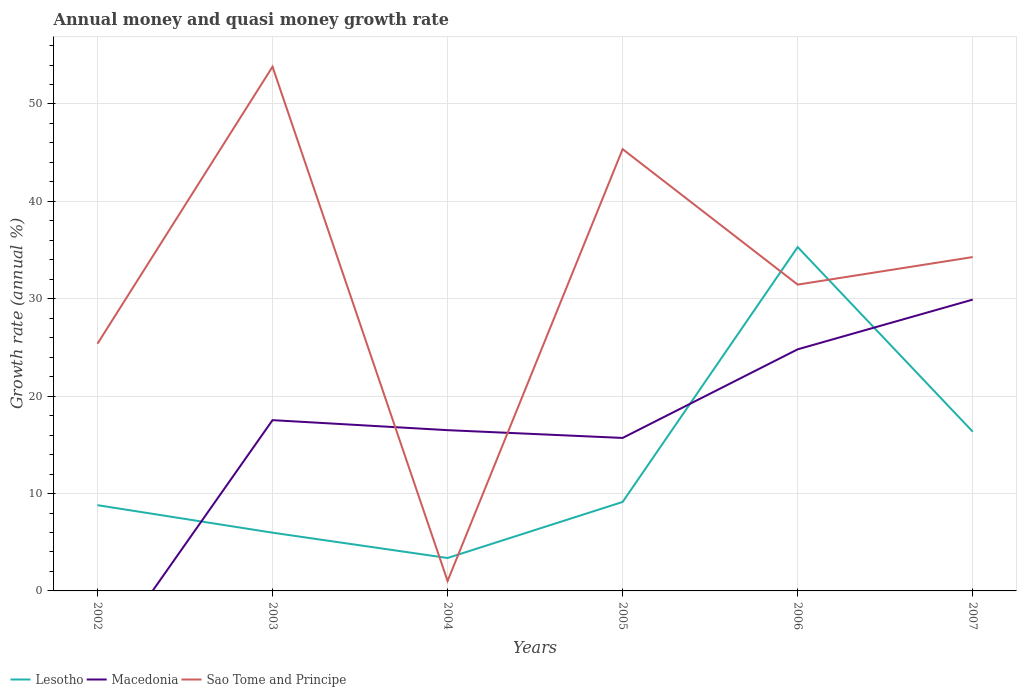How many different coloured lines are there?
Provide a succinct answer. 3. Does the line corresponding to Macedonia intersect with the line corresponding to Sao Tome and Principe?
Your answer should be compact. Yes. Is the number of lines equal to the number of legend labels?
Your answer should be compact. No. Across all years, what is the maximum growth rate in Lesotho?
Ensure brevity in your answer.  3.38. What is the total growth rate in Sao Tome and Principe in the graph?
Provide a succinct answer. 11.08. What is the difference between the highest and the second highest growth rate in Macedonia?
Provide a short and direct response. 29.91. What is the difference between the highest and the lowest growth rate in Macedonia?
Ensure brevity in your answer.  3. How many years are there in the graph?
Ensure brevity in your answer.  6. What is the difference between two consecutive major ticks on the Y-axis?
Your response must be concise. 10. Are the values on the major ticks of Y-axis written in scientific E-notation?
Keep it short and to the point. No. Does the graph contain any zero values?
Make the answer very short. Yes. How many legend labels are there?
Your answer should be compact. 3. What is the title of the graph?
Keep it short and to the point. Annual money and quasi money growth rate. Does "Costa Rica" appear as one of the legend labels in the graph?
Your answer should be very brief. No. What is the label or title of the X-axis?
Make the answer very short. Years. What is the label or title of the Y-axis?
Give a very brief answer. Growth rate (annual %). What is the Growth rate (annual %) of Lesotho in 2002?
Provide a succinct answer. 8.81. What is the Growth rate (annual %) in Macedonia in 2002?
Your answer should be very brief. 0. What is the Growth rate (annual %) in Sao Tome and Principe in 2002?
Provide a short and direct response. 25.38. What is the Growth rate (annual %) in Lesotho in 2003?
Ensure brevity in your answer.  5.98. What is the Growth rate (annual %) in Macedonia in 2003?
Provide a succinct answer. 17.53. What is the Growth rate (annual %) in Sao Tome and Principe in 2003?
Provide a short and direct response. 53.83. What is the Growth rate (annual %) of Lesotho in 2004?
Keep it short and to the point. 3.38. What is the Growth rate (annual %) in Macedonia in 2004?
Provide a succinct answer. 16.51. What is the Growth rate (annual %) in Sao Tome and Principe in 2004?
Your answer should be very brief. 1.02. What is the Growth rate (annual %) of Lesotho in 2005?
Provide a short and direct response. 9.14. What is the Growth rate (annual %) in Macedonia in 2005?
Give a very brief answer. 15.71. What is the Growth rate (annual %) in Sao Tome and Principe in 2005?
Offer a terse response. 45.36. What is the Growth rate (annual %) in Lesotho in 2006?
Your answer should be compact. 35.31. What is the Growth rate (annual %) of Macedonia in 2006?
Ensure brevity in your answer.  24.81. What is the Growth rate (annual %) of Sao Tome and Principe in 2006?
Offer a very short reply. 31.45. What is the Growth rate (annual %) in Lesotho in 2007?
Your answer should be compact. 16.35. What is the Growth rate (annual %) in Macedonia in 2007?
Give a very brief answer. 29.91. What is the Growth rate (annual %) of Sao Tome and Principe in 2007?
Your response must be concise. 34.28. Across all years, what is the maximum Growth rate (annual %) of Lesotho?
Ensure brevity in your answer.  35.31. Across all years, what is the maximum Growth rate (annual %) in Macedonia?
Keep it short and to the point. 29.91. Across all years, what is the maximum Growth rate (annual %) of Sao Tome and Principe?
Ensure brevity in your answer.  53.83. Across all years, what is the minimum Growth rate (annual %) in Lesotho?
Make the answer very short. 3.38. Across all years, what is the minimum Growth rate (annual %) in Macedonia?
Ensure brevity in your answer.  0. Across all years, what is the minimum Growth rate (annual %) in Sao Tome and Principe?
Ensure brevity in your answer.  1.02. What is the total Growth rate (annual %) of Lesotho in the graph?
Ensure brevity in your answer.  78.96. What is the total Growth rate (annual %) of Macedonia in the graph?
Keep it short and to the point. 104.47. What is the total Growth rate (annual %) in Sao Tome and Principe in the graph?
Your response must be concise. 191.32. What is the difference between the Growth rate (annual %) in Lesotho in 2002 and that in 2003?
Your answer should be compact. 2.82. What is the difference between the Growth rate (annual %) of Sao Tome and Principe in 2002 and that in 2003?
Give a very brief answer. -28.44. What is the difference between the Growth rate (annual %) of Lesotho in 2002 and that in 2004?
Your answer should be very brief. 5.42. What is the difference between the Growth rate (annual %) of Sao Tome and Principe in 2002 and that in 2004?
Offer a terse response. 24.37. What is the difference between the Growth rate (annual %) in Lesotho in 2002 and that in 2005?
Your answer should be very brief. -0.33. What is the difference between the Growth rate (annual %) in Sao Tome and Principe in 2002 and that in 2005?
Your answer should be very brief. -19.98. What is the difference between the Growth rate (annual %) in Lesotho in 2002 and that in 2006?
Your answer should be very brief. -26.5. What is the difference between the Growth rate (annual %) of Sao Tome and Principe in 2002 and that in 2006?
Make the answer very short. -6.07. What is the difference between the Growth rate (annual %) in Lesotho in 2002 and that in 2007?
Offer a terse response. -7.54. What is the difference between the Growth rate (annual %) of Sao Tome and Principe in 2002 and that in 2007?
Give a very brief answer. -8.9. What is the difference between the Growth rate (annual %) of Lesotho in 2003 and that in 2004?
Ensure brevity in your answer.  2.6. What is the difference between the Growth rate (annual %) in Macedonia in 2003 and that in 2004?
Make the answer very short. 1.03. What is the difference between the Growth rate (annual %) in Sao Tome and Principe in 2003 and that in 2004?
Ensure brevity in your answer.  52.81. What is the difference between the Growth rate (annual %) of Lesotho in 2003 and that in 2005?
Your response must be concise. -3.15. What is the difference between the Growth rate (annual %) in Macedonia in 2003 and that in 2005?
Make the answer very short. 1.83. What is the difference between the Growth rate (annual %) of Sao Tome and Principe in 2003 and that in 2005?
Ensure brevity in your answer.  8.46. What is the difference between the Growth rate (annual %) of Lesotho in 2003 and that in 2006?
Your answer should be very brief. -29.33. What is the difference between the Growth rate (annual %) of Macedonia in 2003 and that in 2006?
Make the answer very short. -7.27. What is the difference between the Growth rate (annual %) of Sao Tome and Principe in 2003 and that in 2006?
Provide a short and direct response. 22.37. What is the difference between the Growth rate (annual %) in Lesotho in 2003 and that in 2007?
Offer a terse response. -10.37. What is the difference between the Growth rate (annual %) in Macedonia in 2003 and that in 2007?
Offer a very short reply. -12.38. What is the difference between the Growth rate (annual %) of Sao Tome and Principe in 2003 and that in 2007?
Offer a terse response. 19.55. What is the difference between the Growth rate (annual %) of Lesotho in 2004 and that in 2005?
Offer a terse response. -5.75. What is the difference between the Growth rate (annual %) in Macedonia in 2004 and that in 2005?
Provide a short and direct response. 0.8. What is the difference between the Growth rate (annual %) in Sao Tome and Principe in 2004 and that in 2005?
Make the answer very short. -44.34. What is the difference between the Growth rate (annual %) in Lesotho in 2004 and that in 2006?
Your answer should be very brief. -31.92. What is the difference between the Growth rate (annual %) in Macedonia in 2004 and that in 2006?
Your response must be concise. -8.3. What is the difference between the Growth rate (annual %) in Sao Tome and Principe in 2004 and that in 2006?
Your response must be concise. -30.43. What is the difference between the Growth rate (annual %) in Lesotho in 2004 and that in 2007?
Ensure brevity in your answer.  -12.97. What is the difference between the Growth rate (annual %) in Macedonia in 2004 and that in 2007?
Offer a terse response. -13.4. What is the difference between the Growth rate (annual %) in Sao Tome and Principe in 2004 and that in 2007?
Your response must be concise. -33.26. What is the difference between the Growth rate (annual %) in Lesotho in 2005 and that in 2006?
Provide a succinct answer. -26.17. What is the difference between the Growth rate (annual %) in Macedonia in 2005 and that in 2006?
Make the answer very short. -9.1. What is the difference between the Growth rate (annual %) in Sao Tome and Principe in 2005 and that in 2006?
Offer a very short reply. 13.91. What is the difference between the Growth rate (annual %) in Lesotho in 2005 and that in 2007?
Keep it short and to the point. -7.21. What is the difference between the Growth rate (annual %) in Macedonia in 2005 and that in 2007?
Your answer should be very brief. -14.2. What is the difference between the Growth rate (annual %) in Sao Tome and Principe in 2005 and that in 2007?
Make the answer very short. 11.08. What is the difference between the Growth rate (annual %) in Lesotho in 2006 and that in 2007?
Your response must be concise. 18.96. What is the difference between the Growth rate (annual %) of Macedonia in 2006 and that in 2007?
Give a very brief answer. -5.11. What is the difference between the Growth rate (annual %) in Sao Tome and Principe in 2006 and that in 2007?
Keep it short and to the point. -2.83. What is the difference between the Growth rate (annual %) in Lesotho in 2002 and the Growth rate (annual %) in Macedonia in 2003?
Provide a short and direct response. -8.73. What is the difference between the Growth rate (annual %) in Lesotho in 2002 and the Growth rate (annual %) in Sao Tome and Principe in 2003?
Your answer should be very brief. -45.02. What is the difference between the Growth rate (annual %) of Lesotho in 2002 and the Growth rate (annual %) of Macedonia in 2004?
Keep it short and to the point. -7.7. What is the difference between the Growth rate (annual %) in Lesotho in 2002 and the Growth rate (annual %) in Sao Tome and Principe in 2004?
Ensure brevity in your answer.  7.79. What is the difference between the Growth rate (annual %) of Lesotho in 2002 and the Growth rate (annual %) of Macedonia in 2005?
Ensure brevity in your answer.  -6.9. What is the difference between the Growth rate (annual %) of Lesotho in 2002 and the Growth rate (annual %) of Sao Tome and Principe in 2005?
Provide a succinct answer. -36.56. What is the difference between the Growth rate (annual %) in Lesotho in 2002 and the Growth rate (annual %) in Macedonia in 2006?
Provide a succinct answer. -16. What is the difference between the Growth rate (annual %) in Lesotho in 2002 and the Growth rate (annual %) in Sao Tome and Principe in 2006?
Your response must be concise. -22.65. What is the difference between the Growth rate (annual %) in Lesotho in 2002 and the Growth rate (annual %) in Macedonia in 2007?
Your answer should be very brief. -21.11. What is the difference between the Growth rate (annual %) in Lesotho in 2002 and the Growth rate (annual %) in Sao Tome and Principe in 2007?
Your response must be concise. -25.47. What is the difference between the Growth rate (annual %) of Lesotho in 2003 and the Growth rate (annual %) of Macedonia in 2004?
Make the answer very short. -10.53. What is the difference between the Growth rate (annual %) in Lesotho in 2003 and the Growth rate (annual %) in Sao Tome and Principe in 2004?
Keep it short and to the point. 4.96. What is the difference between the Growth rate (annual %) of Macedonia in 2003 and the Growth rate (annual %) of Sao Tome and Principe in 2004?
Your response must be concise. 16.52. What is the difference between the Growth rate (annual %) in Lesotho in 2003 and the Growth rate (annual %) in Macedonia in 2005?
Offer a terse response. -9.73. What is the difference between the Growth rate (annual %) in Lesotho in 2003 and the Growth rate (annual %) in Sao Tome and Principe in 2005?
Keep it short and to the point. -39.38. What is the difference between the Growth rate (annual %) of Macedonia in 2003 and the Growth rate (annual %) of Sao Tome and Principe in 2005?
Keep it short and to the point. -27.83. What is the difference between the Growth rate (annual %) of Lesotho in 2003 and the Growth rate (annual %) of Macedonia in 2006?
Offer a very short reply. -18.83. What is the difference between the Growth rate (annual %) in Lesotho in 2003 and the Growth rate (annual %) in Sao Tome and Principe in 2006?
Your answer should be compact. -25.47. What is the difference between the Growth rate (annual %) in Macedonia in 2003 and the Growth rate (annual %) in Sao Tome and Principe in 2006?
Your response must be concise. -13.92. What is the difference between the Growth rate (annual %) in Lesotho in 2003 and the Growth rate (annual %) in Macedonia in 2007?
Your answer should be very brief. -23.93. What is the difference between the Growth rate (annual %) of Lesotho in 2003 and the Growth rate (annual %) of Sao Tome and Principe in 2007?
Provide a succinct answer. -28.3. What is the difference between the Growth rate (annual %) in Macedonia in 2003 and the Growth rate (annual %) in Sao Tome and Principe in 2007?
Offer a very short reply. -16.75. What is the difference between the Growth rate (annual %) of Lesotho in 2004 and the Growth rate (annual %) of Macedonia in 2005?
Offer a terse response. -12.33. What is the difference between the Growth rate (annual %) in Lesotho in 2004 and the Growth rate (annual %) in Sao Tome and Principe in 2005?
Ensure brevity in your answer.  -41.98. What is the difference between the Growth rate (annual %) in Macedonia in 2004 and the Growth rate (annual %) in Sao Tome and Principe in 2005?
Provide a succinct answer. -28.85. What is the difference between the Growth rate (annual %) in Lesotho in 2004 and the Growth rate (annual %) in Macedonia in 2006?
Keep it short and to the point. -21.43. What is the difference between the Growth rate (annual %) of Lesotho in 2004 and the Growth rate (annual %) of Sao Tome and Principe in 2006?
Offer a very short reply. -28.07. What is the difference between the Growth rate (annual %) in Macedonia in 2004 and the Growth rate (annual %) in Sao Tome and Principe in 2006?
Your answer should be very brief. -14.94. What is the difference between the Growth rate (annual %) of Lesotho in 2004 and the Growth rate (annual %) of Macedonia in 2007?
Keep it short and to the point. -26.53. What is the difference between the Growth rate (annual %) of Lesotho in 2004 and the Growth rate (annual %) of Sao Tome and Principe in 2007?
Give a very brief answer. -30.9. What is the difference between the Growth rate (annual %) of Macedonia in 2004 and the Growth rate (annual %) of Sao Tome and Principe in 2007?
Your answer should be very brief. -17.77. What is the difference between the Growth rate (annual %) of Lesotho in 2005 and the Growth rate (annual %) of Macedonia in 2006?
Your answer should be very brief. -15.67. What is the difference between the Growth rate (annual %) of Lesotho in 2005 and the Growth rate (annual %) of Sao Tome and Principe in 2006?
Your answer should be compact. -22.32. What is the difference between the Growth rate (annual %) in Macedonia in 2005 and the Growth rate (annual %) in Sao Tome and Principe in 2006?
Provide a short and direct response. -15.74. What is the difference between the Growth rate (annual %) of Lesotho in 2005 and the Growth rate (annual %) of Macedonia in 2007?
Your answer should be compact. -20.78. What is the difference between the Growth rate (annual %) of Lesotho in 2005 and the Growth rate (annual %) of Sao Tome and Principe in 2007?
Provide a succinct answer. -25.14. What is the difference between the Growth rate (annual %) in Macedonia in 2005 and the Growth rate (annual %) in Sao Tome and Principe in 2007?
Your answer should be very brief. -18.57. What is the difference between the Growth rate (annual %) of Lesotho in 2006 and the Growth rate (annual %) of Macedonia in 2007?
Offer a terse response. 5.39. What is the difference between the Growth rate (annual %) in Lesotho in 2006 and the Growth rate (annual %) in Sao Tome and Principe in 2007?
Offer a very short reply. 1.03. What is the difference between the Growth rate (annual %) of Macedonia in 2006 and the Growth rate (annual %) of Sao Tome and Principe in 2007?
Provide a succinct answer. -9.47. What is the average Growth rate (annual %) in Lesotho per year?
Make the answer very short. 13.16. What is the average Growth rate (annual %) in Macedonia per year?
Your response must be concise. 17.41. What is the average Growth rate (annual %) of Sao Tome and Principe per year?
Offer a terse response. 31.89. In the year 2002, what is the difference between the Growth rate (annual %) of Lesotho and Growth rate (annual %) of Sao Tome and Principe?
Make the answer very short. -16.58. In the year 2003, what is the difference between the Growth rate (annual %) of Lesotho and Growth rate (annual %) of Macedonia?
Offer a terse response. -11.55. In the year 2003, what is the difference between the Growth rate (annual %) of Lesotho and Growth rate (annual %) of Sao Tome and Principe?
Give a very brief answer. -47.84. In the year 2003, what is the difference between the Growth rate (annual %) of Macedonia and Growth rate (annual %) of Sao Tome and Principe?
Keep it short and to the point. -36.29. In the year 2004, what is the difference between the Growth rate (annual %) in Lesotho and Growth rate (annual %) in Macedonia?
Make the answer very short. -13.13. In the year 2004, what is the difference between the Growth rate (annual %) of Lesotho and Growth rate (annual %) of Sao Tome and Principe?
Your answer should be compact. 2.36. In the year 2004, what is the difference between the Growth rate (annual %) in Macedonia and Growth rate (annual %) in Sao Tome and Principe?
Your response must be concise. 15.49. In the year 2005, what is the difference between the Growth rate (annual %) of Lesotho and Growth rate (annual %) of Macedonia?
Provide a short and direct response. -6.57. In the year 2005, what is the difference between the Growth rate (annual %) in Lesotho and Growth rate (annual %) in Sao Tome and Principe?
Your answer should be compact. -36.23. In the year 2005, what is the difference between the Growth rate (annual %) in Macedonia and Growth rate (annual %) in Sao Tome and Principe?
Your answer should be very brief. -29.65. In the year 2006, what is the difference between the Growth rate (annual %) of Lesotho and Growth rate (annual %) of Macedonia?
Give a very brief answer. 10.5. In the year 2006, what is the difference between the Growth rate (annual %) in Lesotho and Growth rate (annual %) in Sao Tome and Principe?
Your answer should be compact. 3.85. In the year 2006, what is the difference between the Growth rate (annual %) in Macedonia and Growth rate (annual %) in Sao Tome and Principe?
Keep it short and to the point. -6.64. In the year 2007, what is the difference between the Growth rate (annual %) in Lesotho and Growth rate (annual %) in Macedonia?
Ensure brevity in your answer.  -13.56. In the year 2007, what is the difference between the Growth rate (annual %) in Lesotho and Growth rate (annual %) in Sao Tome and Principe?
Your answer should be compact. -17.93. In the year 2007, what is the difference between the Growth rate (annual %) of Macedonia and Growth rate (annual %) of Sao Tome and Principe?
Provide a short and direct response. -4.37. What is the ratio of the Growth rate (annual %) of Lesotho in 2002 to that in 2003?
Make the answer very short. 1.47. What is the ratio of the Growth rate (annual %) of Sao Tome and Principe in 2002 to that in 2003?
Give a very brief answer. 0.47. What is the ratio of the Growth rate (annual %) in Lesotho in 2002 to that in 2004?
Provide a short and direct response. 2.6. What is the ratio of the Growth rate (annual %) of Sao Tome and Principe in 2002 to that in 2004?
Make the answer very short. 24.93. What is the ratio of the Growth rate (annual %) of Lesotho in 2002 to that in 2005?
Provide a short and direct response. 0.96. What is the ratio of the Growth rate (annual %) of Sao Tome and Principe in 2002 to that in 2005?
Provide a short and direct response. 0.56. What is the ratio of the Growth rate (annual %) of Lesotho in 2002 to that in 2006?
Keep it short and to the point. 0.25. What is the ratio of the Growth rate (annual %) in Sao Tome and Principe in 2002 to that in 2006?
Give a very brief answer. 0.81. What is the ratio of the Growth rate (annual %) in Lesotho in 2002 to that in 2007?
Give a very brief answer. 0.54. What is the ratio of the Growth rate (annual %) of Sao Tome and Principe in 2002 to that in 2007?
Offer a terse response. 0.74. What is the ratio of the Growth rate (annual %) of Lesotho in 2003 to that in 2004?
Provide a short and direct response. 1.77. What is the ratio of the Growth rate (annual %) in Macedonia in 2003 to that in 2004?
Your response must be concise. 1.06. What is the ratio of the Growth rate (annual %) of Sao Tome and Principe in 2003 to that in 2004?
Your answer should be very brief. 52.86. What is the ratio of the Growth rate (annual %) in Lesotho in 2003 to that in 2005?
Keep it short and to the point. 0.65. What is the ratio of the Growth rate (annual %) in Macedonia in 2003 to that in 2005?
Keep it short and to the point. 1.12. What is the ratio of the Growth rate (annual %) in Sao Tome and Principe in 2003 to that in 2005?
Your answer should be very brief. 1.19. What is the ratio of the Growth rate (annual %) of Lesotho in 2003 to that in 2006?
Keep it short and to the point. 0.17. What is the ratio of the Growth rate (annual %) of Macedonia in 2003 to that in 2006?
Give a very brief answer. 0.71. What is the ratio of the Growth rate (annual %) in Sao Tome and Principe in 2003 to that in 2006?
Keep it short and to the point. 1.71. What is the ratio of the Growth rate (annual %) of Lesotho in 2003 to that in 2007?
Ensure brevity in your answer.  0.37. What is the ratio of the Growth rate (annual %) in Macedonia in 2003 to that in 2007?
Give a very brief answer. 0.59. What is the ratio of the Growth rate (annual %) of Sao Tome and Principe in 2003 to that in 2007?
Your answer should be compact. 1.57. What is the ratio of the Growth rate (annual %) in Lesotho in 2004 to that in 2005?
Give a very brief answer. 0.37. What is the ratio of the Growth rate (annual %) of Macedonia in 2004 to that in 2005?
Provide a short and direct response. 1.05. What is the ratio of the Growth rate (annual %) in Sao Tome and Principe in 2004 to that in 2005?
Your response must be concise. 0.02. What is the ratio of the Growth rate (annual %) of Lesotho in 2004 to that in 2006?
Provide a succinct answer. 0.1. What is the ratio of the Growth rate (annual %) of Macedonia in 2004 to that in 2006?
Provide a succinct answer. 0.67. What is the ratio of the Growth rate (annual %) of Sao Tome and Principe in 2004 to that in 2006?
Provide a short and direct response. 0.03. What is the ratio of the Growth rate (annual %) of Lesotho in 2004 to that in 2007?
Make the answer very short. 0.21. What is the ratio of the Growth rate (annual %) in Macedonia in 2004 to that in 2007?
Ensure brevity in your answer.  0.55. What is the ratio of the Growth rate (annual %) of Sao Tome and Principe in 2004 to that in 2007?
Offer a terse response. 0.03. What is the ratio of the Growth rate (annual %) in Lesotho in 2005 to that in 2006?
Provide a short and direct response. 0.26. What is the ratio of the Growth rate (annual %) of Macedonia in 2005 to that in 2006?
Offer a very short reply. 0.63. What is the ratio of the Growth rate (annual %) of Sao Tome and Principe in 2005 to that in 2006?
Provide a succinct answer. 1.44. What is the ratio of the Growth rate (annual %) of Lesotho in 2005 to that in 2007?
Make the answer very short. 0.56. What is the ratio of the Growth rate (annual %) in Macedonia in 2005 to that in 2007?
Provide a succinct answer. 0.53. What is the ratio of the Growth rate (annual %) of Sao Tome and Principe in 2005 to that in 2007?
Keep it short and to the point. 1.32. What is the ratio of the Growth rate (annual %) in Lesotho in 2006 to that in 2007?
Your response must be concise. 2.16. What is the ratio of the Growth rate (annual %) of Macedonia in 2006 to that in 2007?
Give a very brief answer. 0.83. What is the ratio of the Growth rate (annual %) of Sao Tome and Principe in 2006 to that in 2007?
Give a very brief answer. 0.92. What is the difference between the highest and the second highest Growth rate (annual %) of Lesotho?
Give a very brief answer. 18.96. What is the difference between the highest and the second highest Growth rate (annual %) in Macedonia?
Provide a short and direct response. 5.11. What is the difference between the highest and the second highest Growth rate (annual %) in Sao Tome and Principe?
Provide a short and direct response. 8.46. What is the difference between the highest and the lowest Growth rate (annual %) of Lesotho?
Keep it short and to the point. 31.92. What is the difference between the highest and the lowest Growth rate (annual %) in Macedonia?
Ensure brevity in your answer.  29.91. What is the difference between the highest and the lowest Growth rate (annual %) of Sao Tome and Principe?
Offer a terse response. 52.81. 